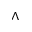<formula> <loc_0><loc_0><loc_500><loc_500>\wedge</formula> 